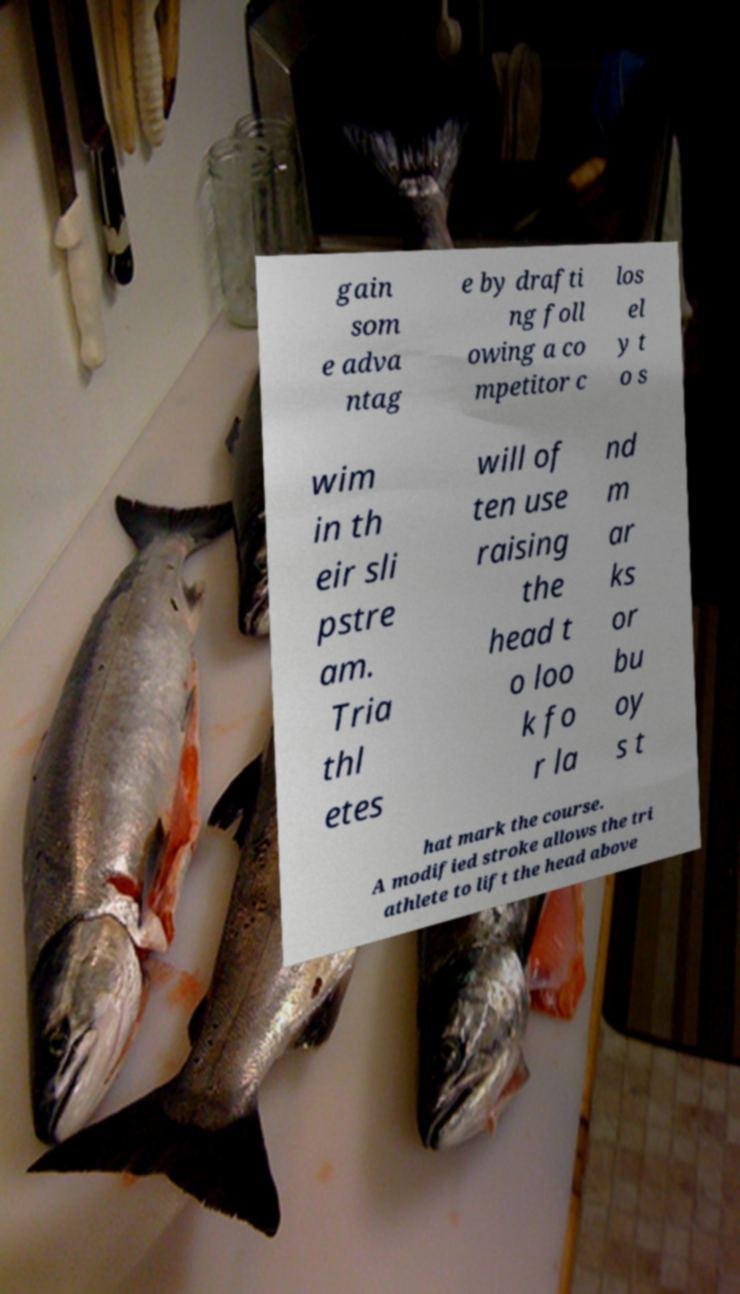Can you accurately transcribe the text from the provided image for me? gain som e adva ntag e by drafti ng foll owing a co mpetitor c los el y t o s wim in th eir sli pstre am. Tria thl etes will of ten use raising the head t o loo k fo r la nd m ar ks or bu oy s t hat mark the course. A modified stroke allows the tri athlete to lift the head above 